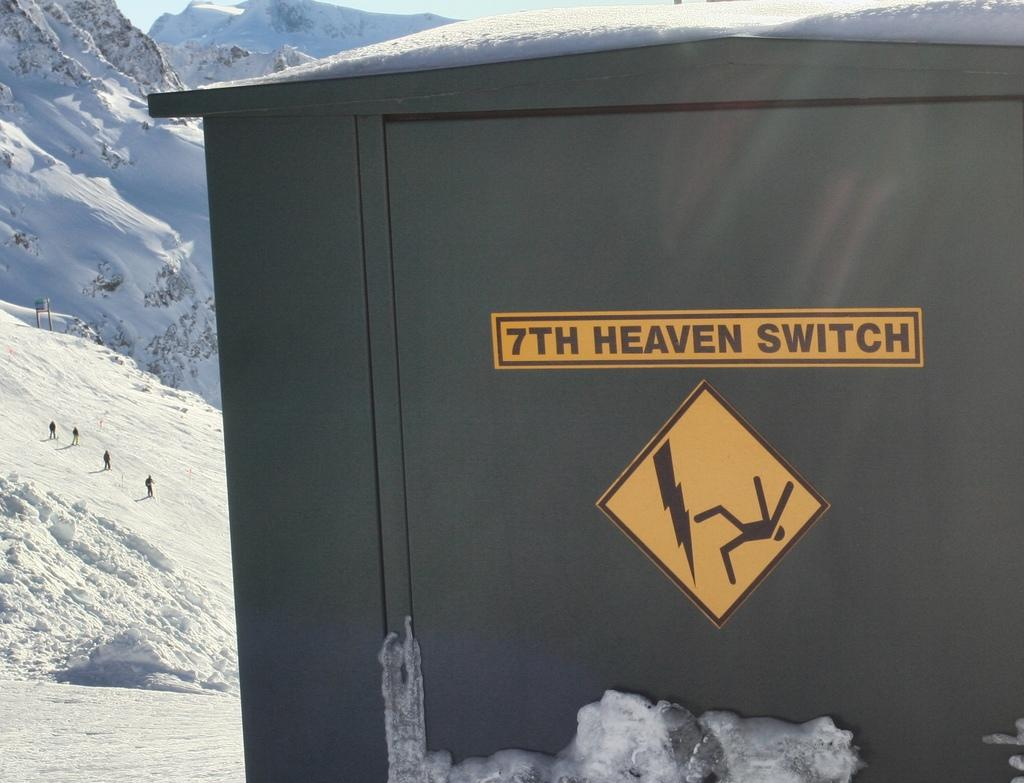<image>
Offer a succinct explanation of the picture presented. A container in front of a snowy mountain has the words 7TH HEAVEN SWITCH on it. 